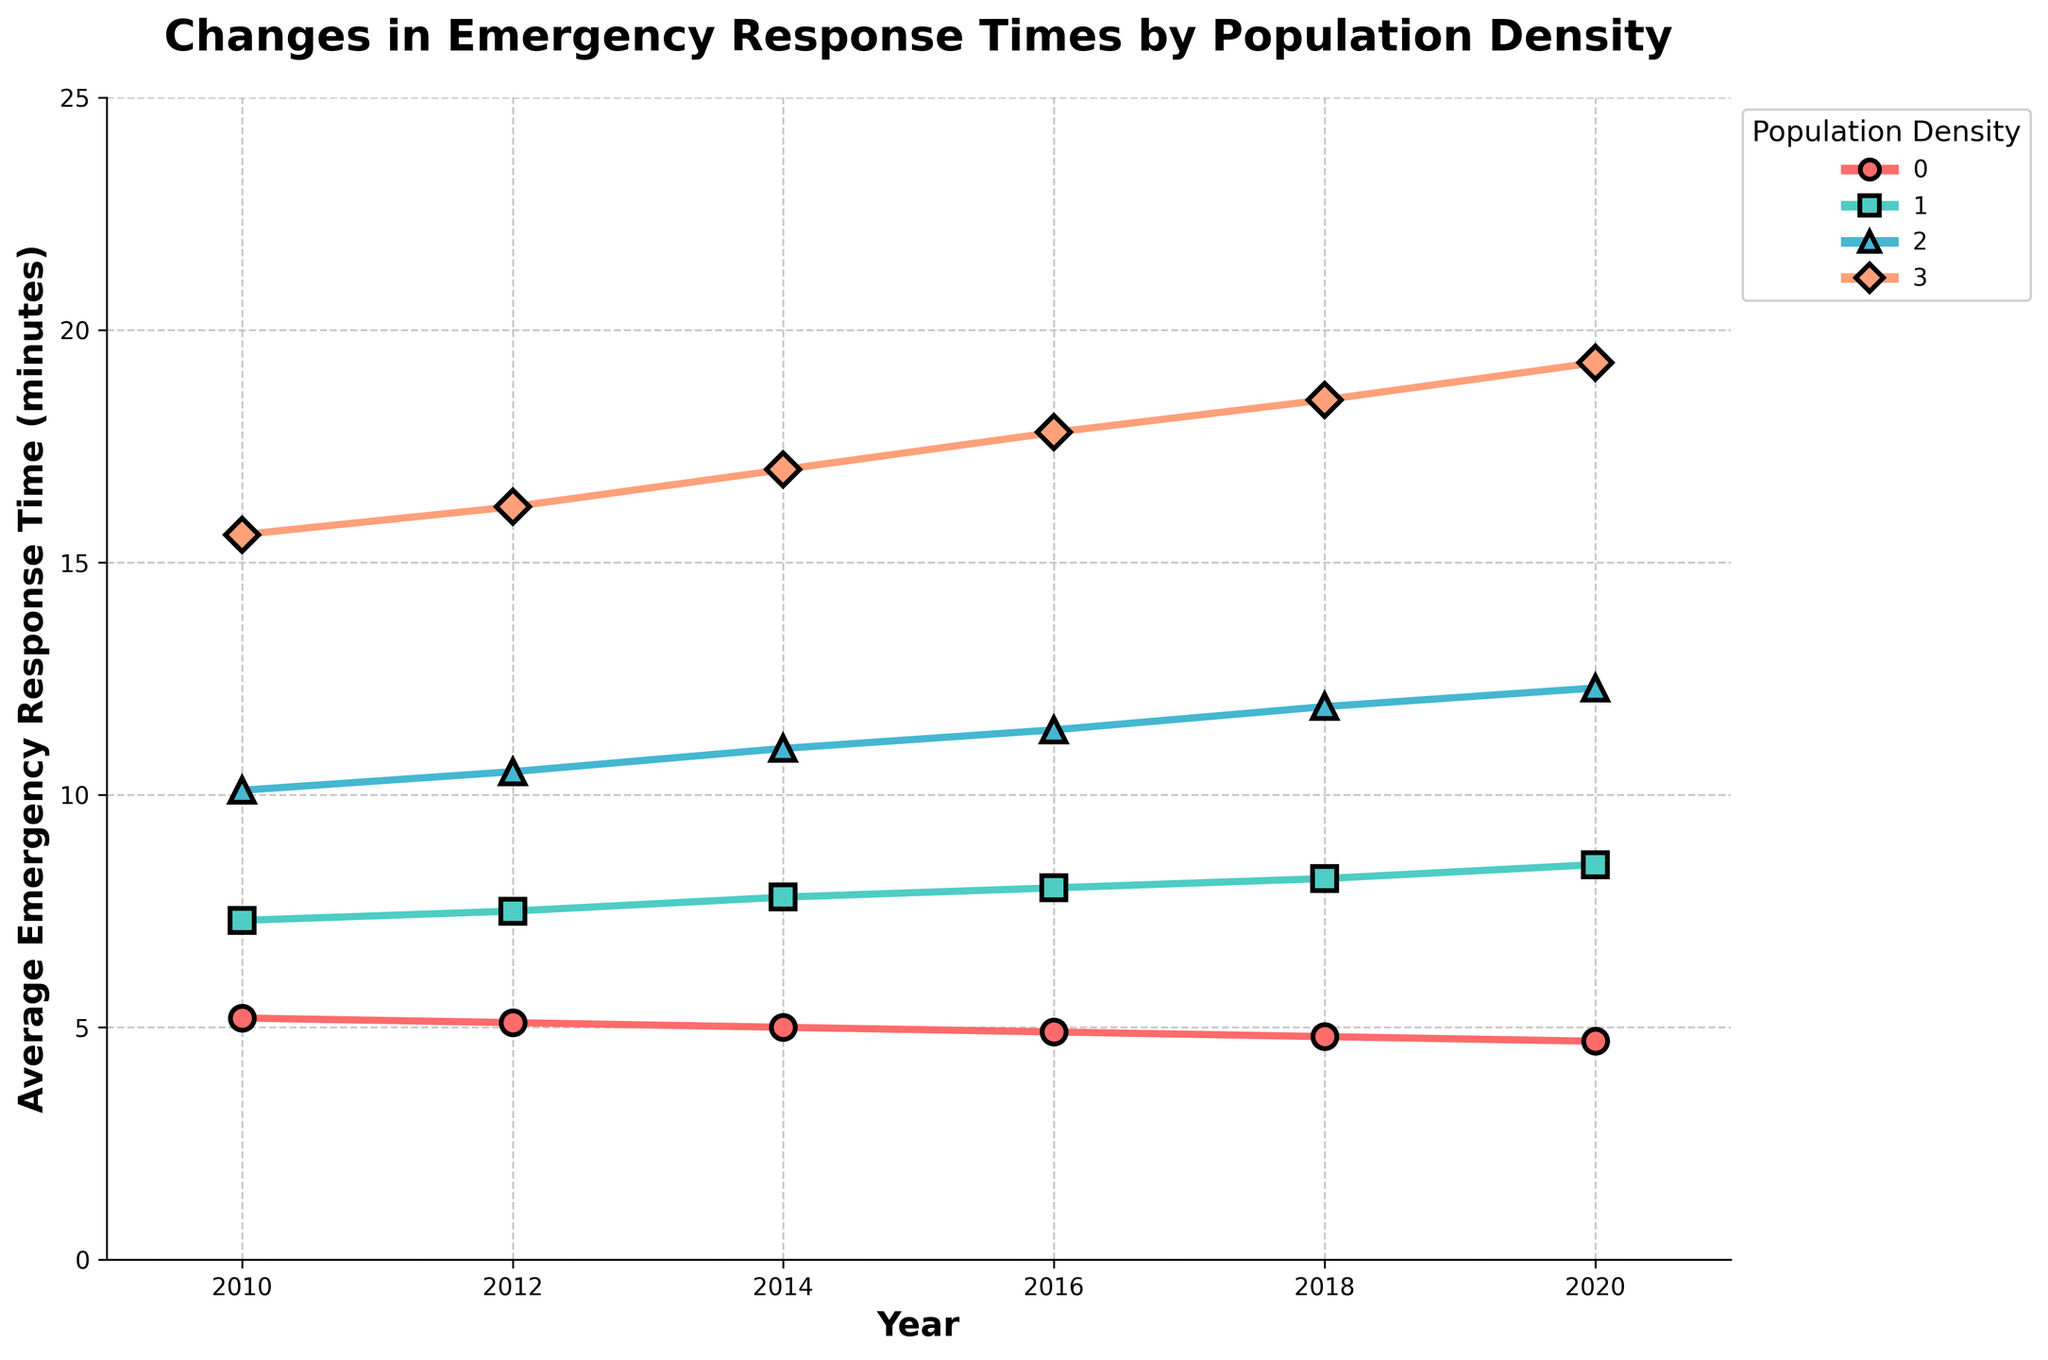What is the trend in emergency response times for urban areas? All data points from 2010 to 2020 show a decrease in average emergency response times for urban areas from 5.2 minutes to 4.7 minutes.
Answer: Decreasing Which area had the highest emergency response time in 2020? In 2020, the rural area had the highest emergency response time at 19.3 minutes.
Answer: Rural How do the emergency response times in 2020 for suburban and small-town areas compare? In 2020, suburban areas had an emergency response time of 8.5 minutes, while small-town areas had a response time of 12.3 minutes. Thus, the response time in small-town areas is higher than in suburban areas.
Answer: Small town > Suburban What is the overall difference in emergency response time between rural and urban areas in 2020? Subtract the 2020 response time for urban areas (4.7 minutes) from the response time for rural areas (19.3 minutes). The difference is 19.3 - 4.7 = 14.6 minutes.
Answer: 14.6 minutes Calculate the average emergency response time for rural areas over the given years. Add the response times for rural areas: 15.6 + 16.2 + 17.0 + 17.8 + 18.5 + 19.3. The sum is 104.4. Divide by the number of years (6): 104.4/6 ≈ 17.4 minutes.
Answer: 17.4 minutes Which population density area showed the greatest increase in emergency response times from 2010 to 2020? The emergency response times for rural areas increased from 15.6 minutes in 2010 to 19.3 minutes in 2020, which is an increase of 3.7 minutes. This is the greatest increase among all the areas.
Answer: Rural How does the trend in emergency response times for suburban areas differ from urban areas? The response time for suburban areas shows an increasing trend from 7.3 minutes in 2010 to 8.5 minutes in 2020, while the response time for urban areas shows a decreasing trend from 5.2 minutes in 2010 to 4.7 minutes in 2020.
Answer: Suburban: increasing, Urban: decreasing Visually, which category is represented by the red line in the plot, and what trend does it show? The red line represents urban areas, and it shows a decreasing trend in emergency response times from 2010 to 2020.
Answer: Urban, decreasing 